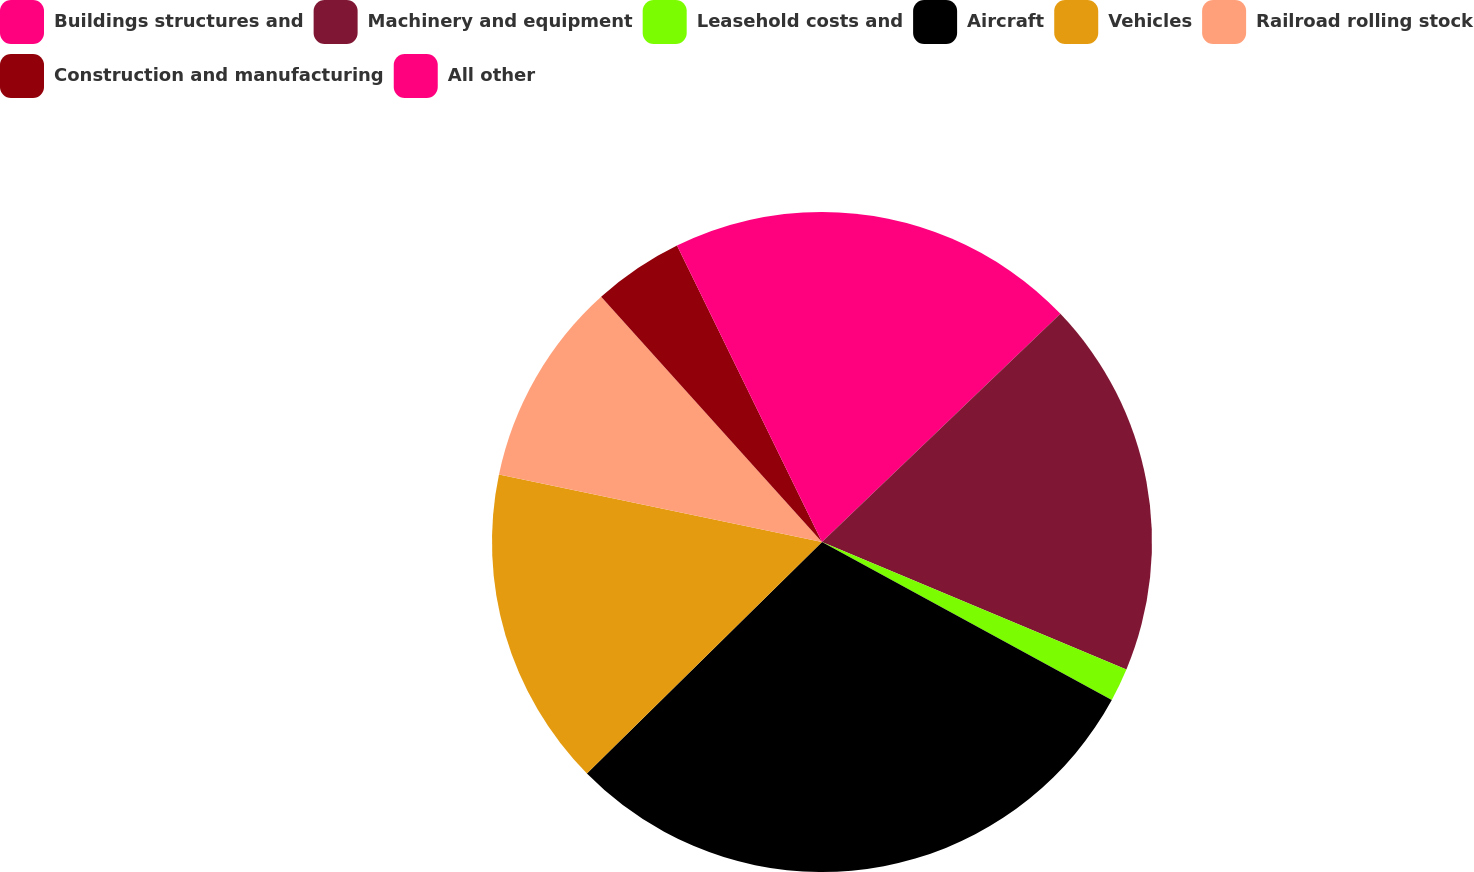Convert chart. <chart><loc_0><loc_0><loc_500><loc_500><pie_chart><fcel>Buildings structures and<fcel>Machinery and equipment<fcel>Leasehold costs and<fcel>Aircraft<fcel>Vehicles<fcel>Railroad rolling stock<fcel>Construction and manufacturing<fcel>All other<nl><fcel>12.85%<fcel>18.46%<fcel>1.63%<fcel>29.68%<fcel>15.66%<fcel>10.05%<fcel>4.43%<fcel>7.24%<nl></chart> 